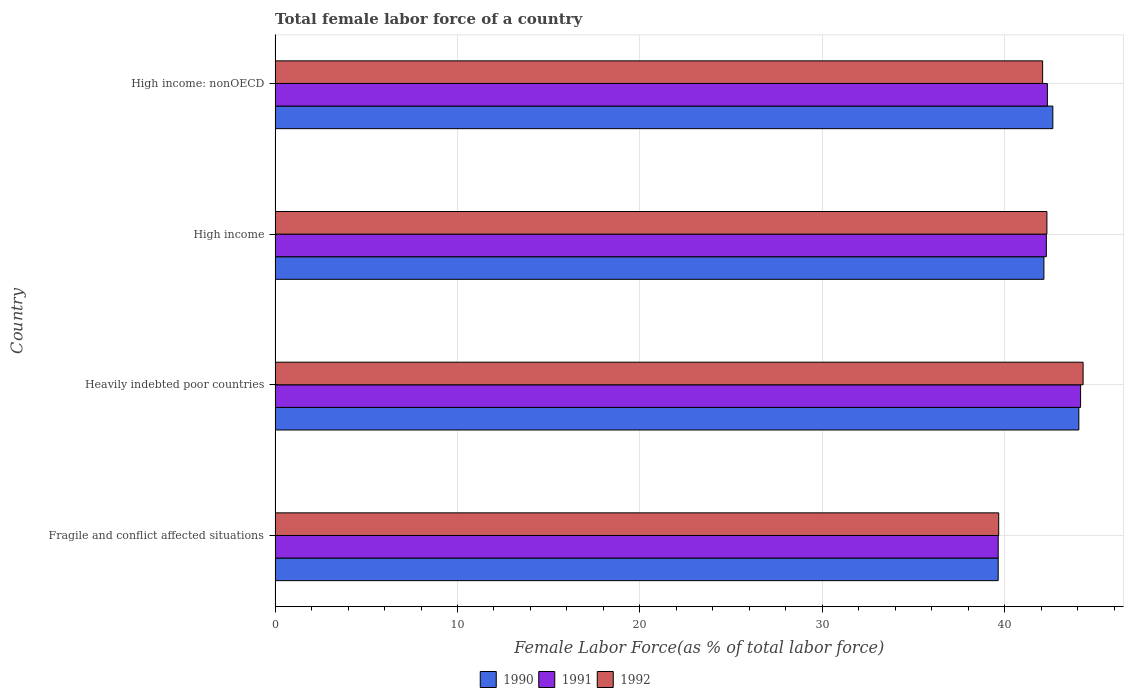How many different coloured bars are there?
Your answer should be very brief. 3. Are the number of bars per tick equal to the number of legend labels?
Your response must be concise. Yes. Are the number of bars on each tick of the Y-axis equal?
Provide a short and direct response. Yes. How many bars are there on the 1st tick from the bottom?
Your answer should be very brief. 3. What is the percentage of female labor force in 1991 in Heavily indebted poor countries?
Provide a succinct answer. 44.16. Across all countries, what is the maximum percentage of female labor force in 1992?
Your response must be concise. 44.3. Across all countries, what is the minimum percentage of female labor force in 1990?
Keep it short and to the point. 39.65. In which country was the percentage of female labor force in 1990 maximum?
Provide a succinct answer. Heavily indebted poor countries. In which country was the percentage of female labor force in 1990 minimum?
Make the answer very short. Fragile and conflict affected situations. What is the total percentage of female labor force in 1991 in the graph?
Provide a short and direct response. 168.44. What is the difference between the percentage of female labor force in 1992 in Fragile and conflict affected situations and that in Heavily indebted poor countries?
Your answer should be very brief. -4.63. What is the difference between the percentage of female labor force in 1991 in Heavily indebted poor countries and the percentage of female labor force in 1990 in High income?
Give a very brief answer. 2.01. What is the average percentage of female labor force in 1992 per country?
Your answer should be very brief. 42.09. What is the difference between the percentage of female labor force in 1991 and percentage of female labor force in 1990 in Heavily indebted poor countries?
Ensure brevity in your answer.  0.1. In how many countries, is the percentage of female labor force in 1991 greater than 38 %?
Offer a terse response. 4. What is the ratio of the percentage of female labor force in 1990 in Heavily indebted poor countries to that in High income?
Provide a short and direct response. 1.05. Is the percentage of female labor force in 1990 in Fragile and conflict affected situations less than that in High income: nonOECD?
Your answer should be very brief. Yes. What is the difference between the highest and the second highest percentage of female labor force in 1991?
Your response must be concise. 1.82. What is the difference between the highest and the lowest percentage of female labor force in 1992?
Offer a terse response. 4.63. What does the 1st bar from the top in Heavily indebted poor countries represents?
Offer a terse response. 1992. Are all the bars in the graph horizontal?
Offer a terse response. Yes. Does the graph contain any zero values?
Offer a very short reply. No. Does the graph contain grids?
Give a very brief answer. Yes. How many legend labels are there?
Your response must be concise. 3. What is the title of the graph?
Give a very brief answer. Total female labor force of a country. Does "1980" appear as one of the legend labels in the graph?
Give a very brief answer. No. What is the label or title of the X-axis?
Ensure brevity in your answer.  Female Labor Force(as % of total labor force). What is the label or title of the Y-axis?
Offer a very short reply. Country. What is the Female Labor Force(as % of total labor force) in 1990 in Fragile and conflict affected situations?
Your response must be concise. 39.65. What is the Female Labor Force(as % of total labor force) in 1991 in Fragile and conflict affected situations?
Your answer should be compact. 39.65. What is the Female Labor Force(as % of total labor force) of 1992 in Fragile and conflict affected situations?
Offer a terse response. 39.67. What is the Female Labor Force(as % of total labor force) in 1990 in Heavily indebted poor countries?
Keep it short and to the point. 44.07. What is the Female Labor Force(as % of total labor force) of 1991 in Heavily indebted poor countries?
Give a very brief answer. 44.16. What is the Female Labor Force(as % of total labor force) of 1992 in Heavily indebted poor countries?
Your answer should be very brief. 44.3. What is the Female Labor Force(as % of total labor force) of 1990 in High income?
Ensure brevity in your answer.  42.15. What is the Female Labor Force(as % of total labor force) in 1991 in High income?
Ensure brevity in your answer.  42.29. What is the Female Labor Force(as % of total labor force) of 1992 in High income?
Provide a succinct answer. 42.32. What is the Female Labor Force(as % of total labor force) in 1990 in High income: nonOECD?
Make the answer very short. 42.64. What is the Female Labor Force(as % of total labor force) in 1991 in High income: nonOECD?
Your answer should be very brief. 42.34. What is the Female Labor Force(as % of total labor force) of 1992 in High income: nonOECD?
Make the answer very short. 42.08. Across all countries, what is the maximum Female Labor Force(as % of total labor force) in 1990?
Give a very brief answer. 44.07. Across all countries, what is the maximum Female Labor Force(as % of total labor force) in 1991?
Your answer should be compact. 44.16. Across all countries, what is the maximum Female Labor Force(as % of total labor force) of 1992?
Your response must be concise. 44.3. Across all countries, what is the minimum Female Labor Force(as % of total labor force) in 1990?
Make the answer very short. 39.65. Across all countries, what is the minimum Female Labor Force(as % of total labor force) in 1991?
Your answer should be very brief. 39.65. Across all countries, what is the minimum Female Labor Force(as % of total labor force) in 1992?
Ensure brevity in your answer.  39.67. What is the total Female Labor Force(as % of total labor force) in 1990 in the graph?
Provide a succinct answer. 168.51. What is the total Female Labor Force(as % of total labor force) in 1991 in the graph?
Your answer should be very brief. 168.44. What is the total Female Labor Force(as % of total labor force) of 1992 in the graph?
Your response must be concise. 168.37. What is the difference between the Female Labor Force(as % of total labor force) in 1990 in Fragile and conflict affected situations and that in Heavily indebted poor countries?
Ensure brevity in your answer.  -4.42. What is the difference between the Female Labor Force(as % of total labor force) of 1991 in Fragile and conflict affected situations and that in Heavily indebted poor countries?
Give a very brief answer. -4.52. What is the difference between the Female Labor Force(as % of total labor force) in 1992 in Fragile and conflict affected situations and that in Heavily indebted poor countries?
Offer a terse response. -4.63. What is the difference between the Female Labor Force(as % of total labor force) of 1990 in Fragile and conflict affected situations and that in High income?
Ensure brevity in your answer.  -2.51. What is the difference between the Female Labor Force(as % of total labor force) of 1991 in Fragile and conflict affected situations and that in High income?
Provide a succinct answer. -2.64. What is the difference between the Female Labor Force(as % of total labor force) of 1992 in Fragile and conflict affected situations and that in High income?
Keep it short and to the point. -2.64. What is the difference between the Female Labor Force(as % of total labor force) in 1990 in Fragile and conflict affected situations and that in High income: nonOECD?
Give a very brief answer. -3. What is the difference between the Female Labor Force(as % of total labor force) of 1991 in Fragile and conflict affected situations and that in High income: nonOECD?
Make the answer very short. -2.7. What is the difference between the Female Labor Force(as % of total labor force) in 1992 in Fragile and conflict affected situations and that in High income: nonOECD?
Offer a very short reply. -2.41. What is the difference between the Female Labor Force(as % of total labor force) of 1990 in Heavily indebted poor countries and that in High income?
Your answer should be compact. 1.92. What is the difference between the Female Labor Force(as % of total labor force) in 1991 in Heavily indebted poor countries and that in High income?
Make the answer very short. 1.88. What is the difference between the Female Labor Force(as % of total labor force) of 1992 in Heavily indebted poor countries and that in High income?
Your answer should be very brief. 1.98. What is the difference between the Female Labor Force(as % of total labor force) of 1990 in Heavily indebted poor countries and that in High income: nonOECD?
Your answer should be very brief. 1.42. What is the difference between the Female Labor Force(as % of total labor force) of 1991 in Heavily indebted poor countries and that in High income: nonOECD?
Offer a very short reply. 1.82. What is the difference between the Female Labor Force(as % of total labor force) of 1992 in Heavily indebted poor countries and that in High income: nonOECD?
Provide a succinct answer. 2.22. What is the difference between the Female Labor Force(as % of total labor force) of 1990 in High income and that in High income: nonOECD?
Provide a short and direct response. -0.49. What is the difference between the Female Labor Force(as % of total labor force) in 1991 in High income and that in High income: nonOECD?
Your response must be concise. -0.06. What is the difference between the Female Labor Force(as % of total labor force) in 1992 in High income and that in High income: nonOECD?
Your answer should be very brief. 0.23. What is the difference between the Female Labor Force(as % of total labor force) in 1990 in Fragile and conflict affected situations and the Female Labor Force(as % of total labor force) in 1991 in Heavily indebted poor countries?
Provide a short and direct response. -4.52. What is the difference between the Female Labor Force(as % of total labor force) in 1990 in Fragile and conflict affected situations and the Female Labor Force(as % of total labor force) in 1992 in Heavily indebted poor countries?
Give a very brief answer. -4.66. What is the difference between the Female Labor Force(as % of total labor force) in 1991 in Fragile and conflict affected situations and the Female Labor Force(as % of total labor force) in 1992 in Heavily indebted poor countries?
Your response must be concise. -4.65. What is the difference between the Female Labor Force(as % of total labor force) in 1990 in Fragile and conflict affected situations and the Female Labor Force(as % of total labor force) in 1991 in High income?
Provide a short and direct response. -2.64. What is the difference between the Female Labor Force(as % of total labor force) in 1990 in Fragile and conflict affected situations and the Female Labor Force(as % of total labor force) in 1992 in High income?
Your response must be concise. -2.67. What is the difference between the Female Labor Force(as % of total labor force) in 1991 in Fragile and conflict affected situations and the Female Labor Force(as % of total labor force) in 1992 in High income?
Make the answer very short. -2.67. What is the difference between the Female Labor Force(as % of total labor force) of 1990 in Fragile and conflict affected situations and the Female Labor Force(as % of total labor force) of 1991 in High income: nonOECD?
Offer a terse response. -2.7. What is the difference between the Female Labor Force(as % of total labor force) in 1990 in Fragile and conflict affected situations and the Female Labor Force(as % of total labor force) in 1992 in High income: nonOECD?
Your answer should be very brief. -2.44. What is the difference between the Female Labor Force(as % of total labor force) in 1991 in Fragile and conflict affected situations and the Female Labor Force(as % of total labor force) in 1992 in High income: nonOECD?
Your response must be concise. -2.44. What is the difference between the Female Labor Force(as % of total labor force) of 1990 in Heavily indebted poor countries and the Female Labor Force(as % of total labor force) of 1991 in High income?
Your answer should be compact. 1.78. What is the difference between the Female Labor Force(as % of total labor force) of 1990 in Heavily indebted poor countries and the Female Labor Force(as % of total labor force) of 1992 in High income?
Keep it short and to the point. 1.75. What is the difference between the Female Labor Force(as % of total labor force) of 1991 in Heavily indebted poor countries and the Female Labor Force(as % of total labor force) of 1992 in High income?
Give a very brief answer. 1.85. What is the difference between the Female Labor Force(as % of total labor force) in 1990 in Heavily indebted poor countries and the Female Labor Force(as % of total labor force) in 1991 in High income: nonOECD?
Your answer should be compact. 1.73. What is the difference between the Female Labor Force(as % of total labor force) in 1990 in Heavily indebted poor countries and the Female Labor Force(as % of total labor force) in 1992 in High income: nonOECD?
Keep it short and to the point. 1.99. What is the difference between the Female Labor Force(as % of total labor force) of 1991 in Heavily indebted poor countries and the Female Labor Force(as % of total labor force) of 1992 in High income: nonOECD?
Offer a very short reply. 2.08. What is the difference between the Female Labor Force(as % of total labor force) of 1990 in High income and the Female Labor Force(as % of total labor force) of 1991 in High income: nonOECD?
Offer a terse response. -0.19. What is the difference between the Female Labor Force(as % of total labor force) of 1990 in High income and the Female Labor Force(as % of total labor force) of 1992 in High income: nonOECD?
Offer a terse response. 0.07. What is the difference between the Female Labor Force(as % of total labor force) of 1991 in High income and the Female Labor Force(as % of total labor force) of 1992 in High income: nonOECD?
Your response must be concise. 0.2. What is the average Female Labor Force(as % of total labor force) of 1990 per country?
Provide a succinct answer. 42.13. What is the average Female Labor Force(as % of total labor force) in 1991 per country?
Your answer should be very brief. 42.11. What is the average Female Labor Force(as % of total labor force) of 1992 per country?
Offer a very short reply. 42.09. What is the difference between the Female Labor Force(as % of total labor force) in 1990 and Female Labor Force(as % of total labor force) in 1991 in Fragile and conflict affected situations?
Make the answer very short. -0. What is the difference between the Female Labor Force(as % of total labor force) of 1990 and Female Labor Force(as % of total labor force) of 1992 in Fragile and conflict affected situations?
Keep it short and to the point. -0.03. What is the difference between the Female Labor Force(as % of total labor force) of 1991 and Female Labor Force(as % of total labor force) of 1992 in Fragile and conflict affected situations?
Make the answer very short. -0.03. What is the difference between the Female Labor Force(as % of total labor force) in 1990 and Female Labor Force(as % of total labor force) in 1991 in Heavily indebted poor countries?
Give a very brief answer. -0.1. What is the difference between the Female Labor Force(as % of total labor force) of 1990 and Female Labor Force(as % of total labor force) of 1992 in Heavily indebted poor countries?
Ensure brevity in your answer.  -0.23. What is the difference between the Female Labor Force(as % of total labor force) of 1991 and Female Labor Force(as % of total labor force) of 1992 in Heavily indebted poor countries?
Keep it short and to the point. -0.14. What is the difference between the Female Labor Force(as % of total labor force) in 1990 and Female Labor Force(as % of total labor force) in 1991 in High income?
Your answer should be compact. -0.13. What is the difference between the Female Labor Force(as % of total labor force) of 1990 and Female Labor Force(as % of total labor force) of 1992 in High income?
Your answer should be very brief. -0.16. What is the difference between the Female Labor Force(as % of total labor force) in 1991 and Female Labor Force(as % of total labor force) in 1992 in High income?
Keep it short and to the point. -0.03. What is the difference between the Female Labor Force(as % of total labor force) of 1990 and Female Labor Force(as % of total labor force) of 1991 in High income: nonOECD?
Keep it short and to the point. 0.3. What is the difference between the Female Labor Force(as % of total labor force) of 1990 and Female Labor Force(as % of total labor force) of 1992 in High income: nonOECD?
Provide a short and direct response. 0.56. What is the difference between the Female Labor Force(as % of total labor force) of 1991 and Female Labor Force(as % of total labor force) of 1992 in High income: nonOECD?
Provide a succinct answer. 0.26. What is the ratio of the Female Labor Force(as % of total labor force) of 1990 in Fragile and conflict affected situations to that in Heavily indebted poor countries?
Your answer should be compact. 0.9. What is the ratio of the Female Labor Force(as % of total labor force) of 1991 in Fragile and conflict affected situations to that in Heavily indebted poor countries?
Offer a terse response. 0.9. What is the ratio of the Female Labor Force(as % of total labor force) of 1992 in Fragile and conflict affected situations to that in Heavily indebted poor countries?
Provide a short and direct response. 0.9. What is the ratio of the Female Labor Force(as % of total labor force) in 1990 in Fragile and conflict affected situations to that in High income?
Offer a very short reply. 0.94. What is the ratio of the Female Labor Force(as % of total labor force) of 1991 in Fragile and conflict affected situations to that in High income?
Provide a short and direct response. 0.94. What is the ratio of the Female Labor Force(as % of total labor force) in 1992 in Fragile and conflict affected situations to that in High income?
Offer a terse response. 0.94. What is the ratio of the Female Labor Force(as % of total labor force) in 1990 in Fragile and conflict affected situations to that in High income: nonOECD?
Offer a very short reply. 0.93. What is the ratio of the Female Labor Force(as % of total labor force) in 1991 in Fragile and conflict affected situations to that in High income: nonOECD?
Your answer should be compact. 0.94. What is the ratio of the Female Labor Force(as % of total labor force) of 1992 in Fragile and conflict affected situations to that in High income: nonOECD?
Offer a terse response. 0.94. What is the ratio of the Female Labor Force(as % of total labor force) in 1990 in Heavily indebted poor countries to that in High income?
Provide a short and direct response. 1.05. What is the ratio of the Female Labor Force(as % of total labor force) of 1991 in Heavily indebted poor countries to that in High income?
Provide a short and direct response. 1.04. What is the ratio of the Female Labor Force(as % of total labor force) of 1992 in Heavily indebted poor countries to that in High income?
Make the answer very short. 1.05. What is the ratio of the Female Labor Force(as % of total labor force) in 1990 in Heavily indebted poor countries to that in High income: nonOECD?
Provide a short and direct response. 1.03. What is the ratio of the Female Labor Force(as % of total labor force) of 1991 in Heavily indebted poor countries to that in High income: nonOECD?
Offer a very short reply. 1.04. What is the ratio of the Female Labor Force(as % of total labor force) of 1992 in Heavily indebted poor countries to that in High income: nonOECD?
Ensure brevity in your answer.  1.05. What is the ratio of the Female Labor Force(as % of total labor force) of 1990 in High income to that in High income: nonOECD?
Ensure brevity in your answer.  0.99. What is the ratio of the Female Labor Force(as % of total labor force) in 1992 in High income to that in High income: nonOECD?
Provide a short and direct response. 1.01. What is the difference between the highest and the second highest Female Labor Force(as % of total labor force) of 1990?
Keep it short and to the point. 1.42. What is the difference between the highest and the second highest Female Labor Force(as % of total labor force) in 1991?
Provide a short and direct response. 1.82. What is the difference between the highest and the second highest Female Labor Force(as % of total labor force) in 1992?
Offer a very short reply. 1.98. What is the difference between the highest and the lowest Female Labor Force(as % of total labor force) of 1990?
Your response must be concise. 4.42. What is the difference between the highest and the lowest Female Labor Force(as % of total labor force) of 1991?
Provide a short and direct response. 4.52. What is the difference between the highest and the lowest Female Labor Force(as % of total labor force) in 1992?
Give a very brief answer. 4.63. 